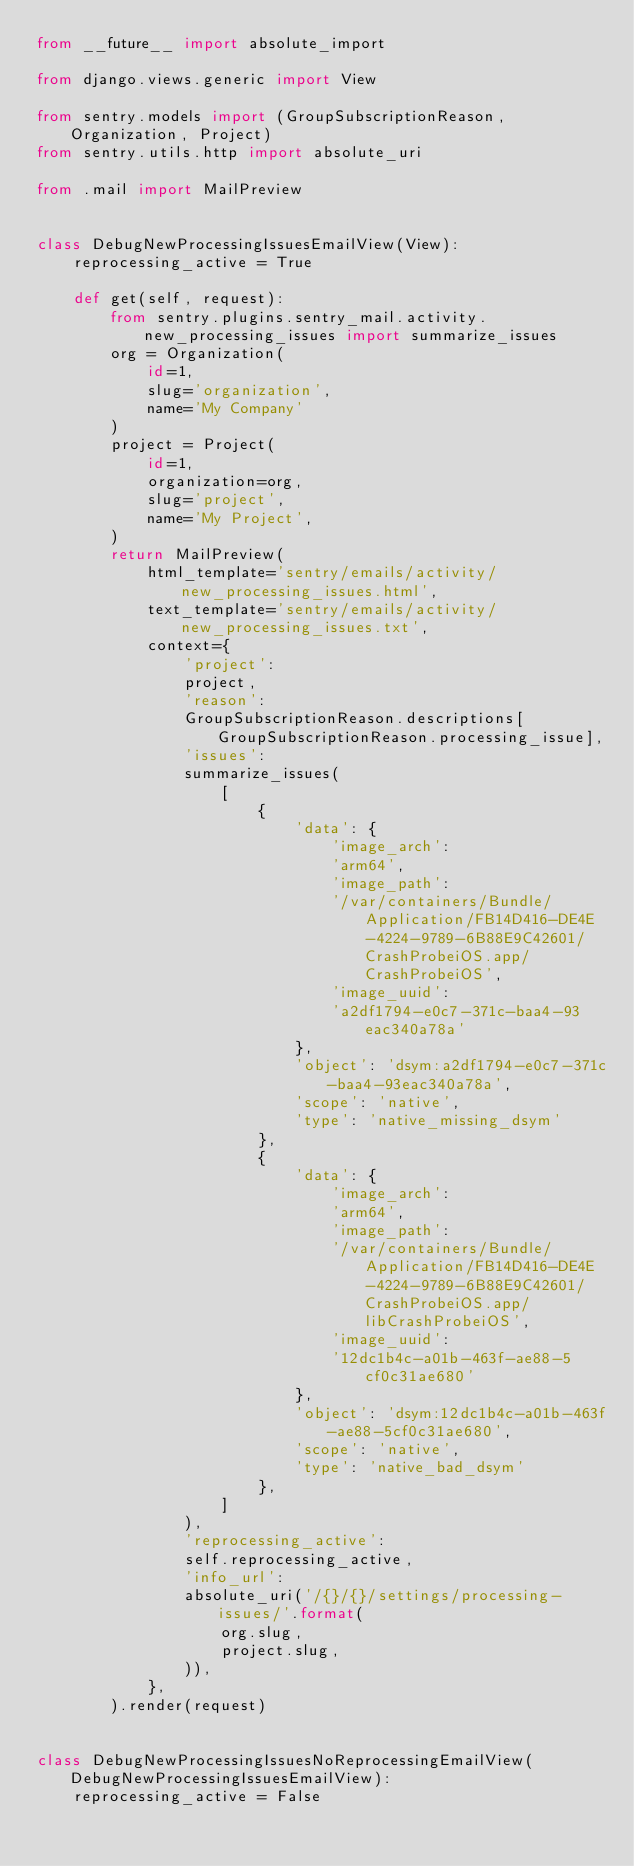Convert code to text. <code><loc_0><loc_0><loc_500><loc_500><_Python_>from __future__ import absolute_import

from django.views.generic import View

from sentry.models import (GroupSubscriptionReason, Organization, Project)
from sentry.utils.http import absolute_uri

from .mail import MailPreview


class DebugNewProcessingIssuesEmailView(View):
    reprocessing_active = True

    def get(self, request):
        from sentry.plugins.sentry_mail.activity.new_processing_issues import summarize_issues
        org = Organization(
            id=1,
            slug='organization',
            name='My Company'
        )
        project = Project(
            id=1,
            organization=org,
            slug='project',
            name='My Project',
        )
        return MailPreview(
            html_template='sentry/emails/activity/new_processing_issues.html',
            text_template='sentry/emails/activity/new_processing_issues.txt',
            context={
                'project':
                project,
                'reason':
                GroupSubscriptionReason.descriptions[GroupSubscriptionReason.processing_issue],
                'issues':
                summarize_issues(
                    [
                        {
                            'data': {
                                'image_arch':
                                'arm64',
                                'image_path':
                                '/var/containers/Bundle/Application/FB14D416-DE4E-4224-9789-6B88E9C42601/CrashProbeiOS.app/CrashProbeiOS',
                                'image_uuid':
                                'a2df1794-e0c7-371c-baa4-93eac340a78a'
                            },
                            'object': 'dsym:a2df1794-e0c7-371c-baa4-93eac340a78a',
                            'scope': 'native',
                            'type': 'native_missing_dsym'
                        },
                        {
                            'data': {
                                'image_arch':
                                'arm64',
                                'image_path':
                                '/var/containers/Bundle/Application/FB14D416-DE4E-4224-9789-6B88E9C42601/CrashProbeiOS.app/libCrashProbeiOS',
                                'image_uuid':
                                '12dc1b4c-a01b-463f-ae88-5cf0c31ae680'
                            },
                            'object': 'dsym:12dc1b4c-a01b-463f-ae88-5cf0c31ae680',
                            'scope': 'native',
                            'type': 'native_bad_dsym'
                        },
                    ]
                ),
                'reprocessing_active':
                self.reprocessing_active,
                'info_url':
                absolute_uri('/{}/{}/settings/processing-issues/'.format(
                    org.slug,
                    project.slug,
                )),
            },
        ).render(request)


class DebugNewProcessingIssuesNoReprocessingEmailView(DebugNewProcessingIssuesEmailView):
    reprocessing_active = False
</code> 